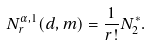<formula> <loc_0><loc_0><loc_500><loc_500>N _ { r } ^ { \alpha , 1 } ( d , m ) = \frac { 1 } { r ! } N _ { 2 } ^ { * } .</formula> 